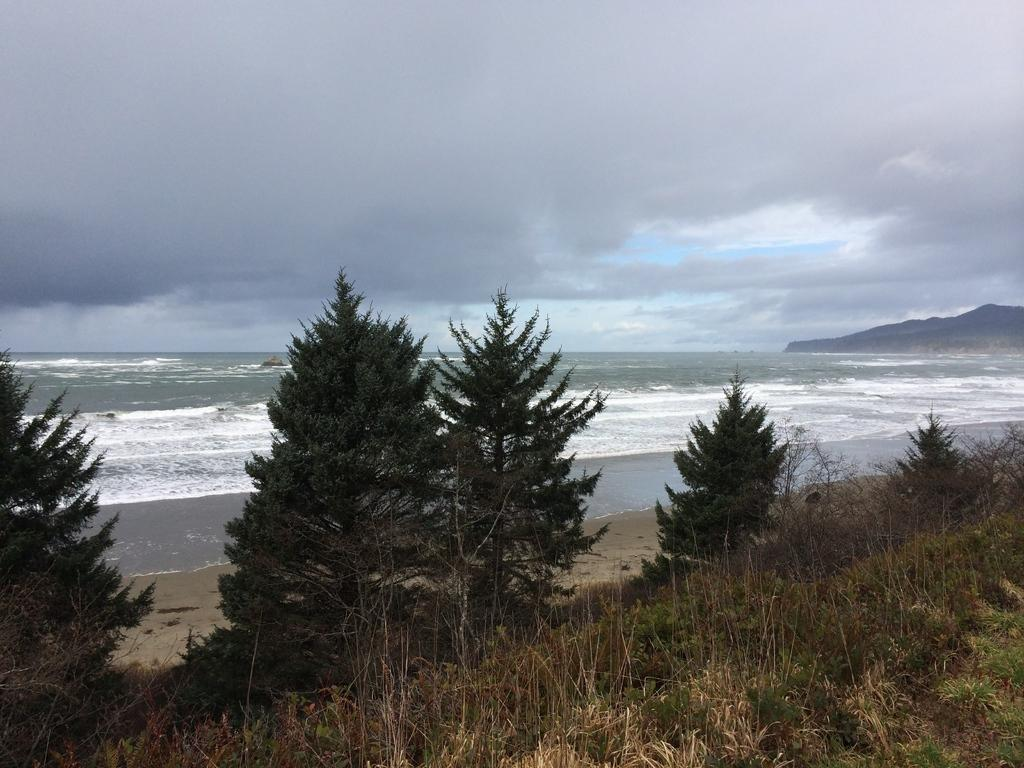What type of vegetation is in the front of the image? There are many trees in the front of the image. What natural feature is visible behind the trees? There is an ocean behind the trees. What geographical feature is on the right side of the image? There is a hill on the right side of the image. What is visible above the image? The sky is visible above the image. What atmospheric conditions can be observed in the sky? Clouds are present in the sky. Where is the scarecrow placed in the image? There is no scarecrow present in the image. What is the ice cream learning in the image? There is no ice cream or learning depicted in the image. 